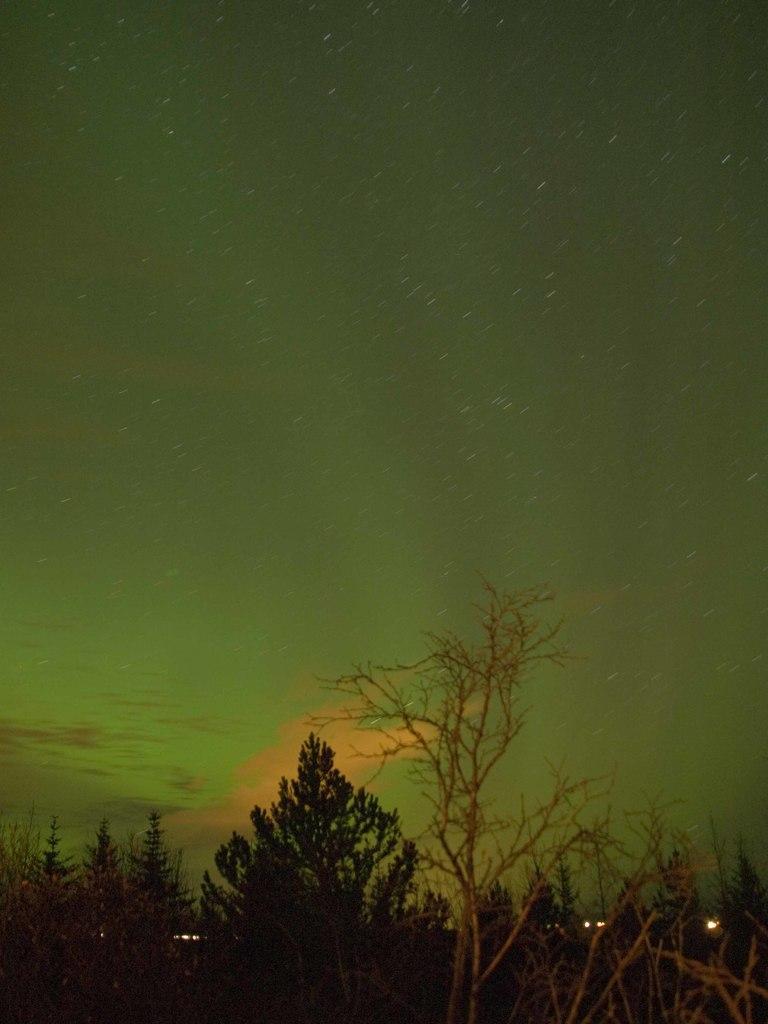What type of natural elements can be seen in the image? There are trees in the image. What artificial elements can be seen in the image? There are lights in the image. What is the dominant color in the background of the image? The background of the image is green. What type of ring can be seen on the tree in the image? There is no ring present on the tree in the image. What trick is being performed with the lights in the image? There is no trick being performed with the lights in the image; they are simply illuminated. 